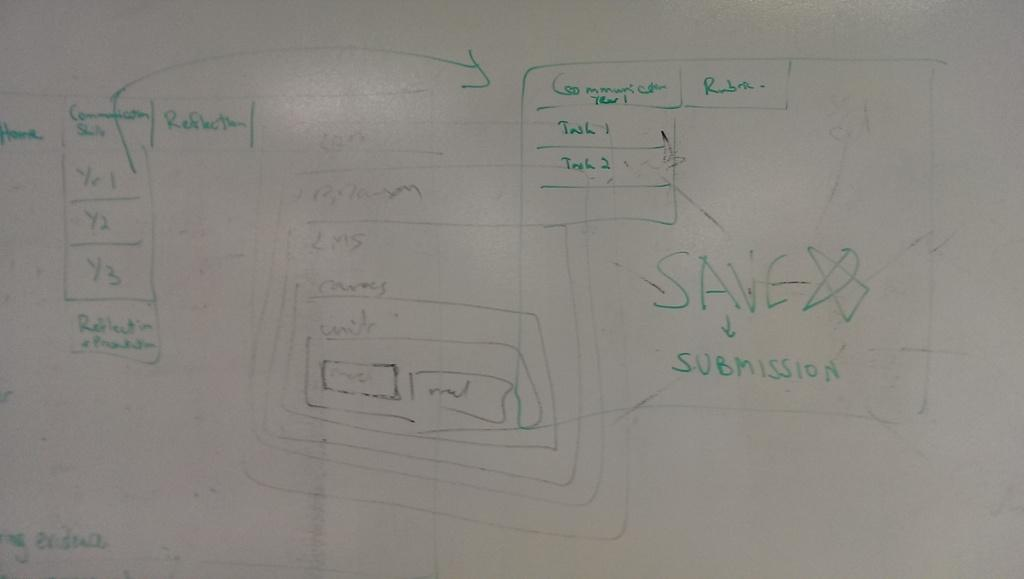<image>
Share a concise interpretation of the image provided. A whiteboard covered in green marker drawings and the word save written above the word submission. 